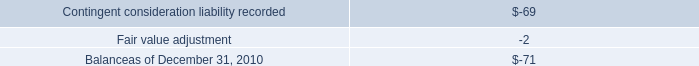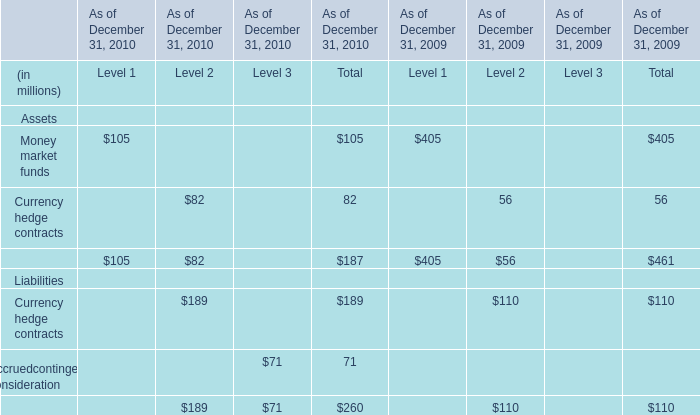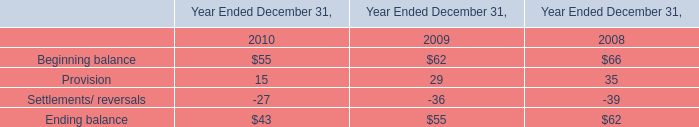What's the 2010 growth rate of Total of Currency hedge contracts? 
Computations: ((189 - 110) / 110)
Answer: 0.71818. 